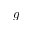<formula> <loc_0><loc_0><loc_500><loc_500>g</formula> 